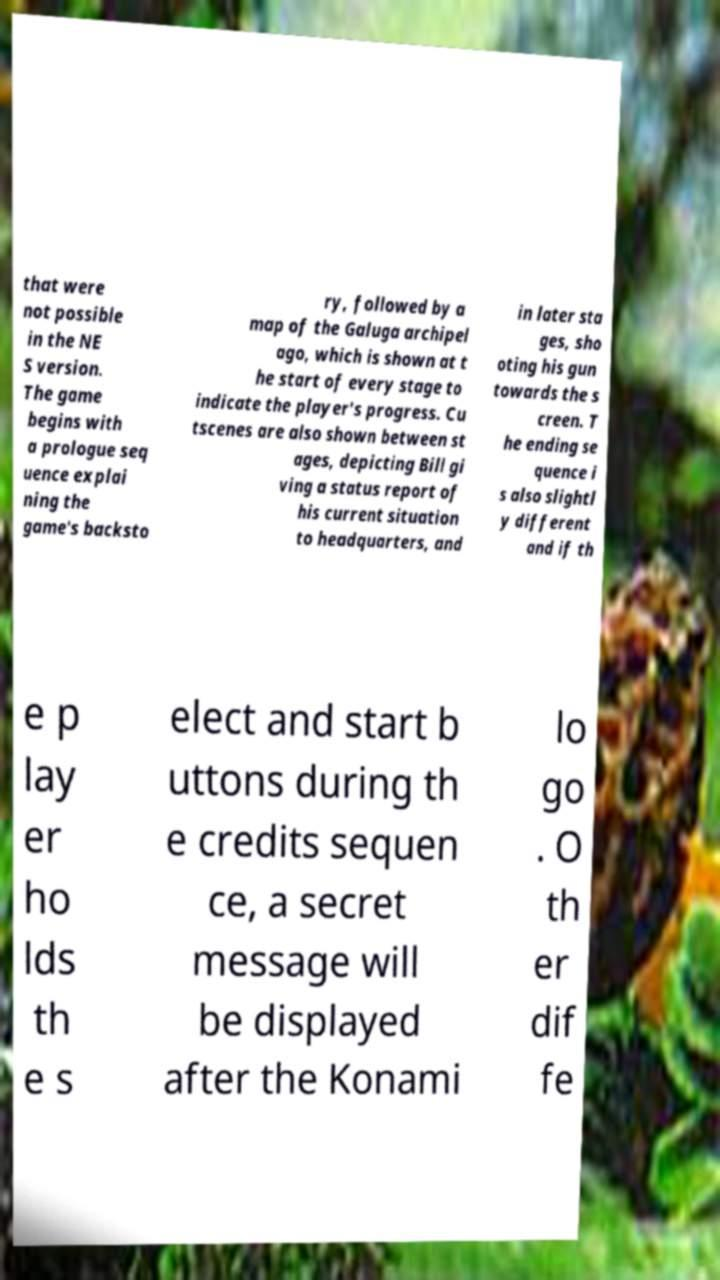There's text embedded in this image that I need extracted. Can you transcribe it verbatim? that were not possible in the NE S version. The game begins with a prologue seq uence explai ning the game's backsto ry, followed by a map of the Galuga archipel ago, which is shown at t he start of every stage to indicate the player's progress. Cu tscenes are also shown between st ages, depicting Bill gi ving a status report of his current situation to headquarters, and in later sta ges, sho oting his gun towards the s creen. T he ending se quence i s also slightl y different and if th e p lay er ho lds th e s elect and start b uttons during th e credits sequen ce, a secret message will be displayed after the Konami lo go . O th er dif fe 